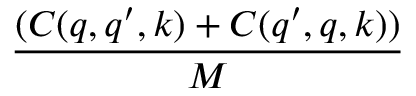<formula> <loc_0><loc_0><loc_500><loc_500>\frac { ( C ( q , q ^ { \prime } , k ) + C ( q ^ { \prime } , q , k ) ) } { M }</formula> 